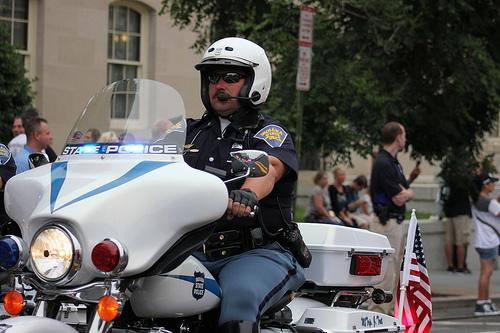Point out any elements related to the police officer's equipment or attire. White helmet with microphone, fingerless gloves, state police patch on sleeve, and walkie talkie on the side of his pants. Identify the primary subject and action in the image. A policeman riding a motorcycle, wearing a white helmet, and a blue uniform shirt. What are some details about the people in the background of the image? A group of people sitting on a concrete wall, a man standing on the curb, a woman with a hat, and a female in shorts staring. Describe any light sources seen in the image. The main headlight of the motorcycle is on, and there are red, white, and blue lights. Mention any specific details about the motorcycle in the image. White police motorcycle with a headlight on, state police logo on windshield, red and white traffic sign, and a small American flag at the end. What are the key visual elements in the image that indicate a sense of authority? Policeman on a motorcycle, state police logo on windshield, state police patch on uniform sleeve, and an American flag on the rear of the motorcycle. List any noticeable items related to traffic or road signs in the image. Red and white traffic sign, a pair of no parking signs, and a sign painted on the front showing state police. Please provide a brief description of the scene in the picture. A police officer on a white motorcycle, surrounded by people standing and sitting on a concrete wall, with an American flag on the rear of the bike. In a few words, describe the atmosphere and setting of the image. Police officer on duty, people observing, tree by the street, windows of a building. Mention any distinctive clothing items or accessories worn by the police officer. White helmet with microphone, black fingerless glove, state police patch on uniform sleeve, and walkie talkie on his pants. 